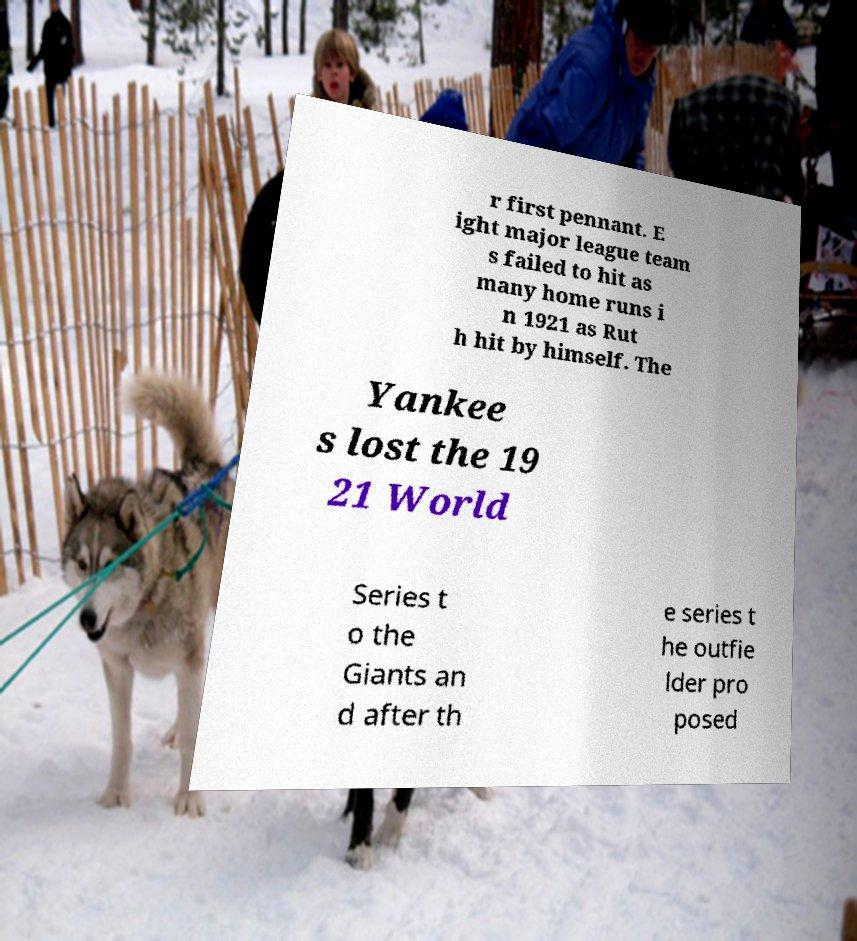Can you read and provide the text displayed in the image?This photo seems to have some interesting text. Can you extract and type it out for me? r first pennant. E ight major league team s failed to hit as many home runs i n 1921 as Rut h hit by himself. The Yankee s lost the 19 21 World Series t o the Giants an d after th e series t he outfie lder pro posed 